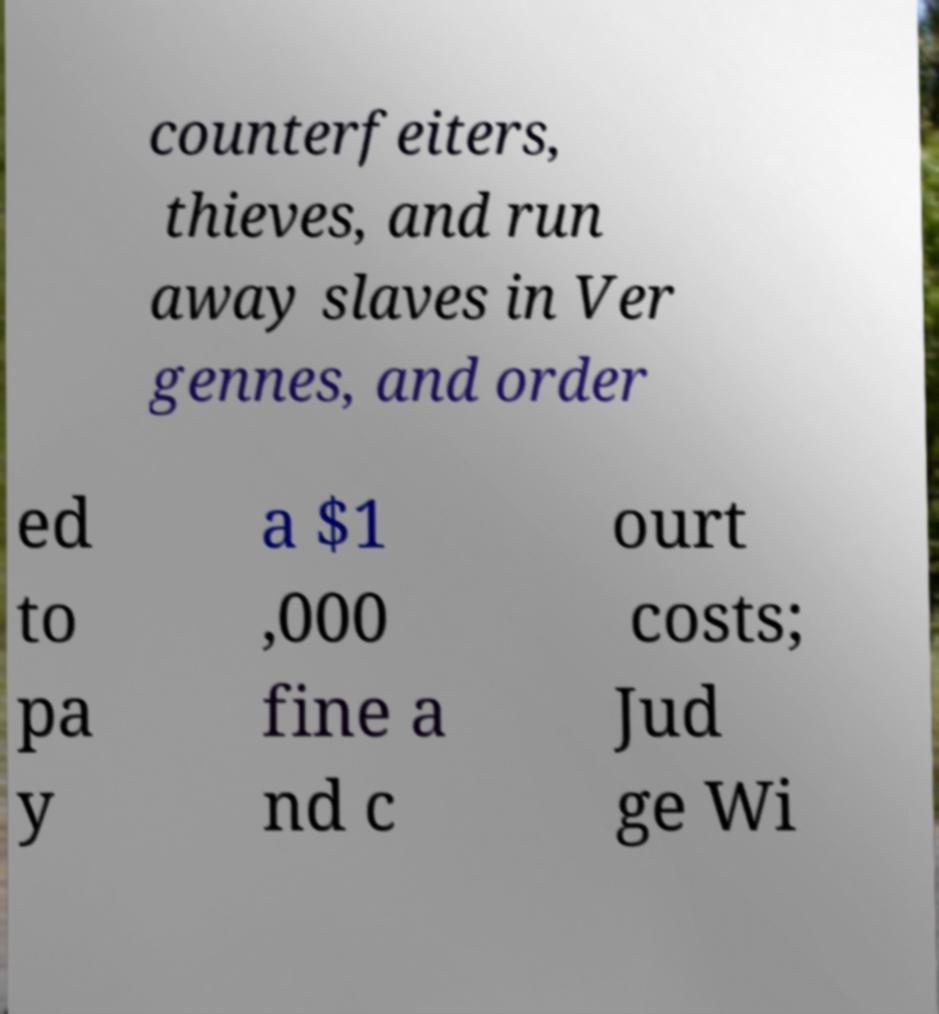Can you accurately transcribe the text from the provided image for me? counterfeiters, thieves, and run away slaves in Ver gennes, and order ed to pa y a $1 ,000 fine a nd c ourt costs; Jud ge Wi 